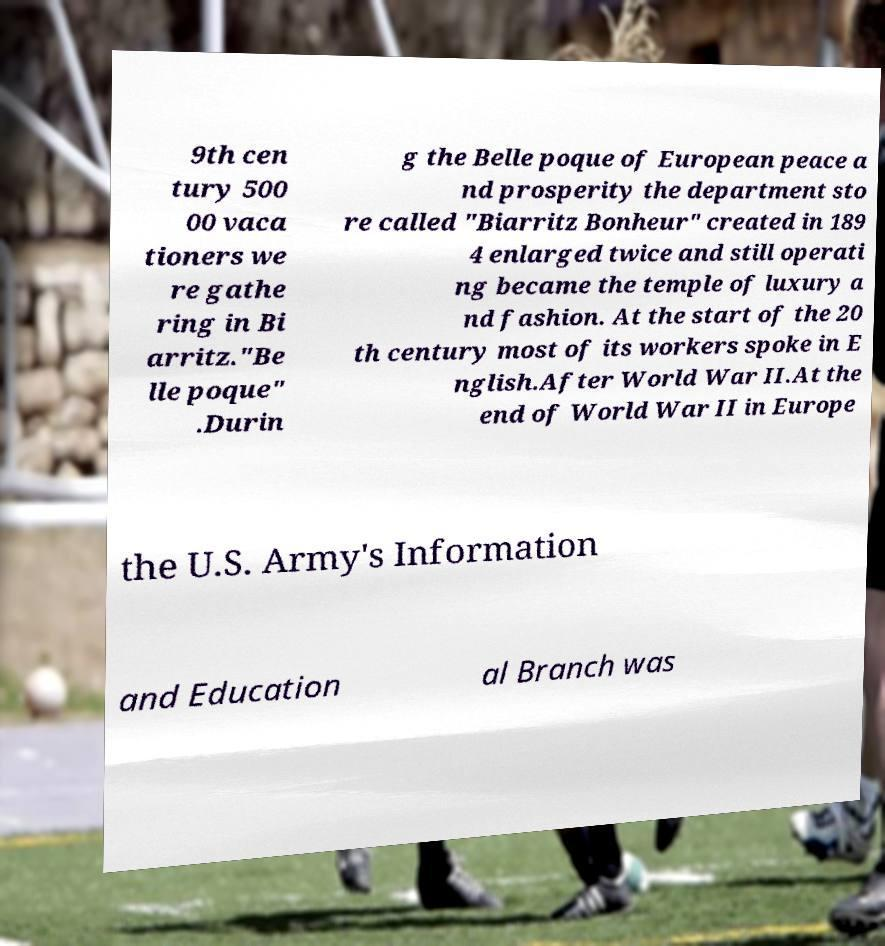Please identify and transcribe the text found in this image. 9th cen tury 500 00 vaca tioners we re gathe ring in Bi arritz."Be lle poque" .Durin g the Belle poque of European peace a nd prosperity the department sto re called "Biarritz Bonheur" created in 189 4 enlarged twice and still operati ng became the temple of luxury a nd fashion. At the start of the 20 th century most of its workers spoke in E nglish.After World War II.At the end of World War II in Europe the U.S. Army's Information and Education al Branch was 